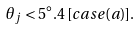Convert formula to latex. <formula><loc_0><loc_0><loc_500><loc_500>\theta _ { j } < 5 ^ { \circ } . 4 \, [ c a s e ( a ) ] .</formula> 